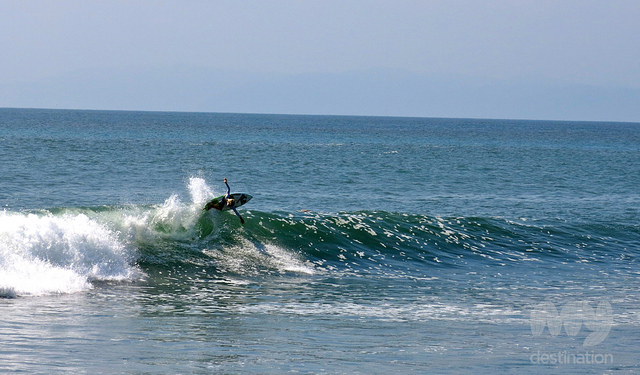Extract all visible text content from this image. destination my 